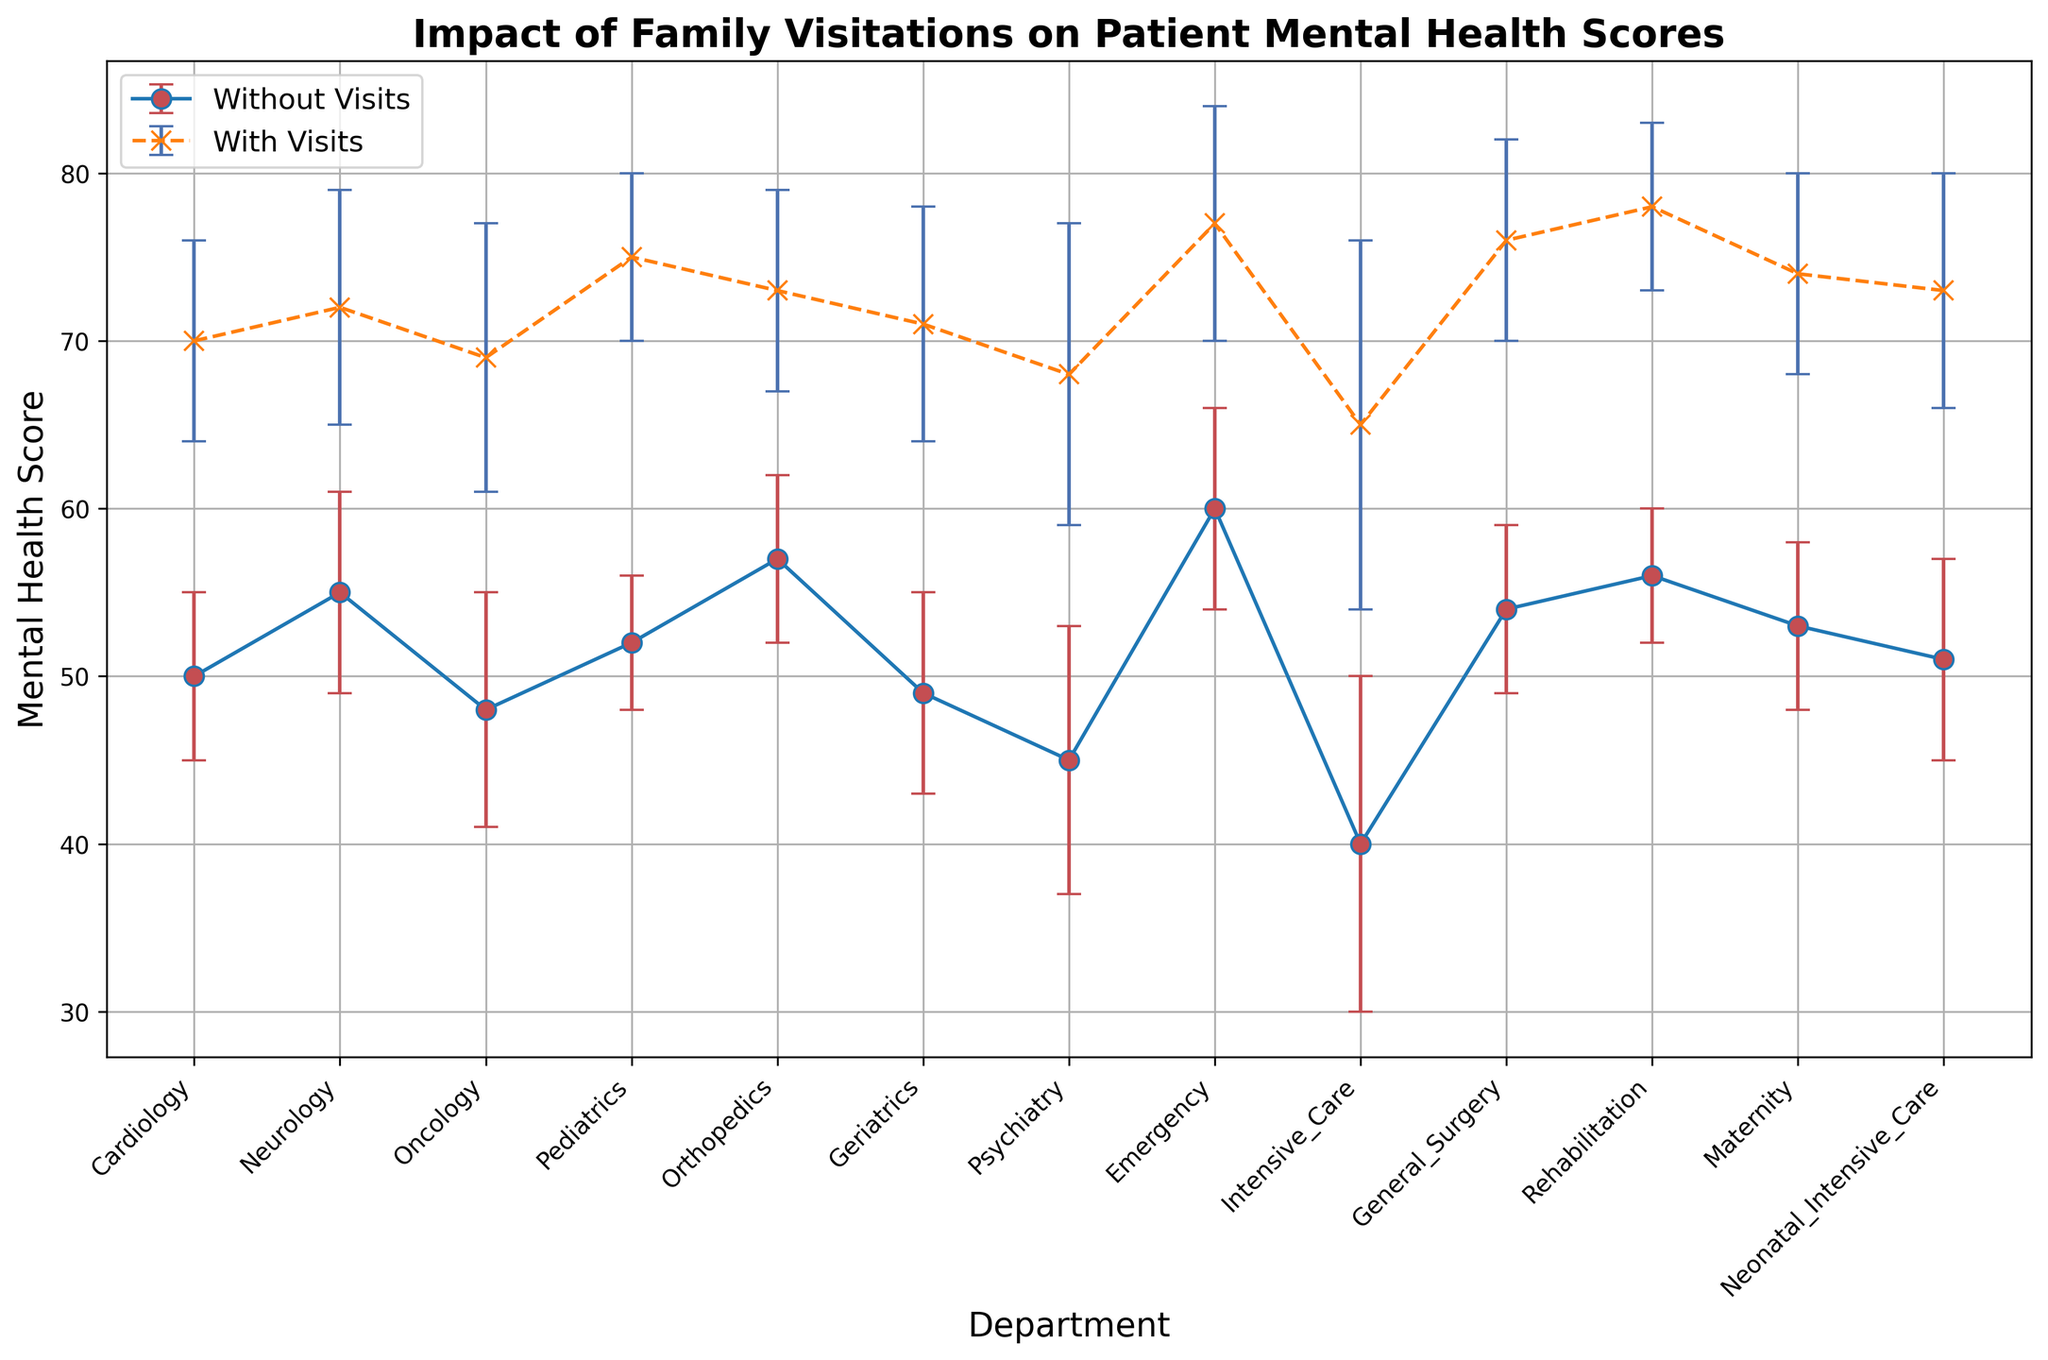What is the highest mean mental health score with family visits? The highest mean score can be seen as the tallest blue "x" marker on the plot. Looking at all departments, the Emergency department with visits has a score of 77.
Answer: 77 Which department shows the largest improvement in mental health scores with family visits? To determine the largest improvement, we look at both the "Without Visits" and "With Visits" scores and calculate the difference for each department. The Emergency department shows an improvement from 60 to 77, a difference of 17, which is the highest.
Answer: Emergency Which department has the smallest standard deviation in mental health scores with family visits? The smallest standard deviation with family visits corresponds to the smallest blue error bar. The Pediatrics department has a standard deviation of 5, which is the smallest among all.
Answer: Pediatrics Which departments have a mean mental health score without family visits that is above 55? To find this, we check which red "o" markers are above the 55 mean score line without considering their error bars. The departments are Neurology, Orthopedics, Emergency, General Surgery, and Rehabilitation.
Answer: Neurology, Orthopedics, Emergency, General Surgery, Rehabilitation What is the difference in mental health scores between Pediatrics and Psychiatry with family visits? Look at the mean scores for both Pediatrics and Psychiatry with visits. Pediatrics has a mean score of 75, while Psychiatry has a mean score of 68. The difference is 75 - 68 = 7.
Answer: 7 Which department shows the least impact of family visits on mental health scores? Identify the smallest difference between the "Without Visits" and "With Visits" scores. The Geriatrics department shows a change from 49 to 71, a difference of only 22, which is the smallest impact.
Answer: Geriatrics How does the standard deviation for the Intensive Care department with visits compare to that without visits? Look at the length of the error bars for the Intensive Care department. With visits, the standard deviation is 11, and without visits, it is 10, showing that it's slightly larger with visits.
Answer: Slightly larger What is the average mean mental health score with family visits across all departments? Sum the mean scores with family visits for all departments and divide by the number of departments. The sum is 70 + 72 + 69 + 75 + 73 + 71 + 68 + 77 + 65 + 76 + 78 + 74 + 73 = 941, and there are 13 departments, so the average is 941 / 13 = 72.38.
Answer: 72.38 